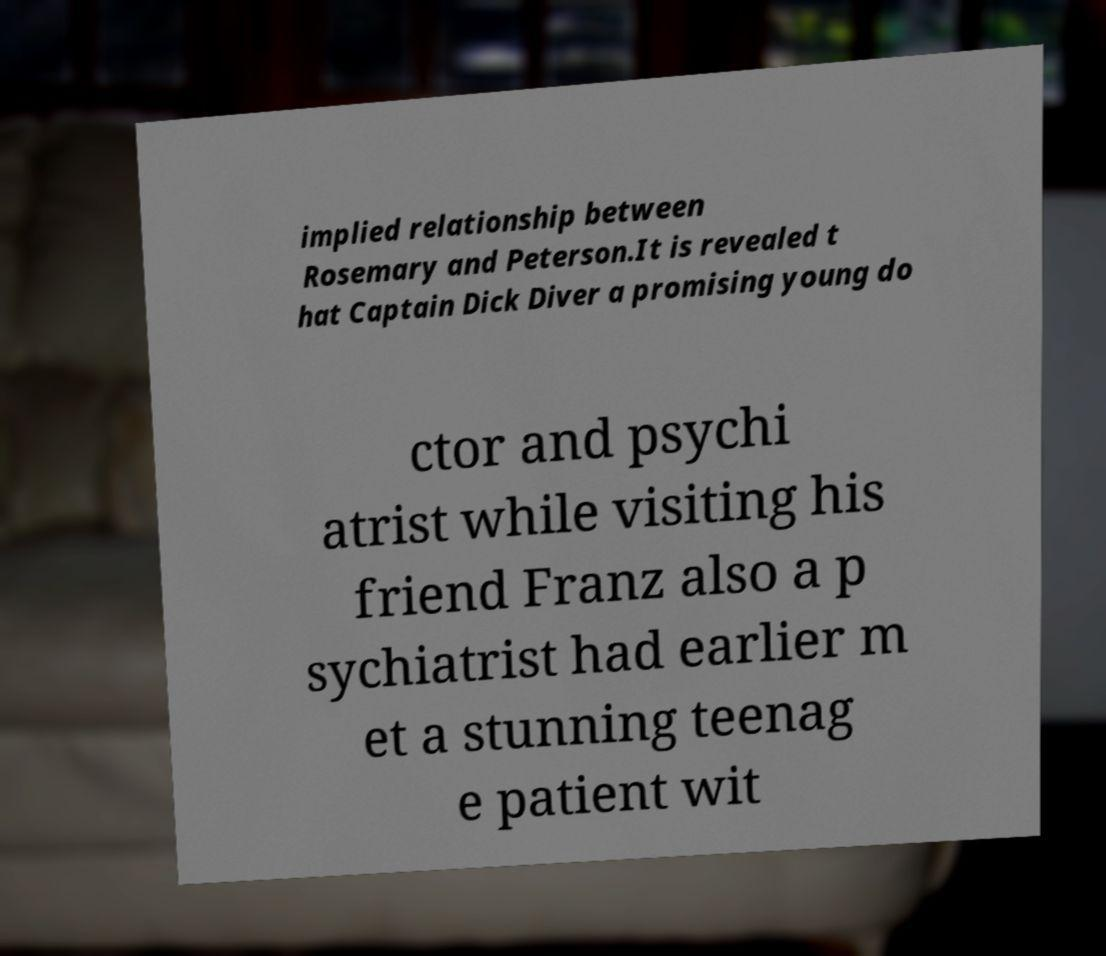Please identify and transcribe the text found in this image. implied relationship between Rosemary and Peterson.It is revealed t hat Captain Dick Diver a promising young do ctor and psychi atrist while visiting his friend Franz also a p sychiatrist had earlier m et a stunning teenag e patient wit 